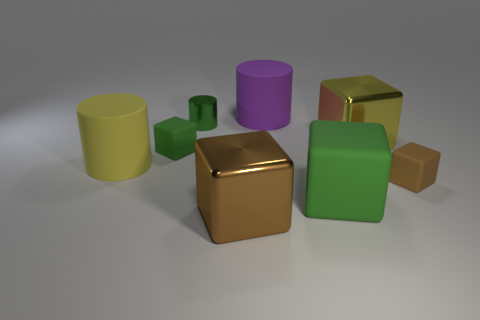What is the color of the small cylinder that is made of the same material as the big brown thing? The small cylinder that is made of the same shiny, reflective material as the large brown cube is green in color. 